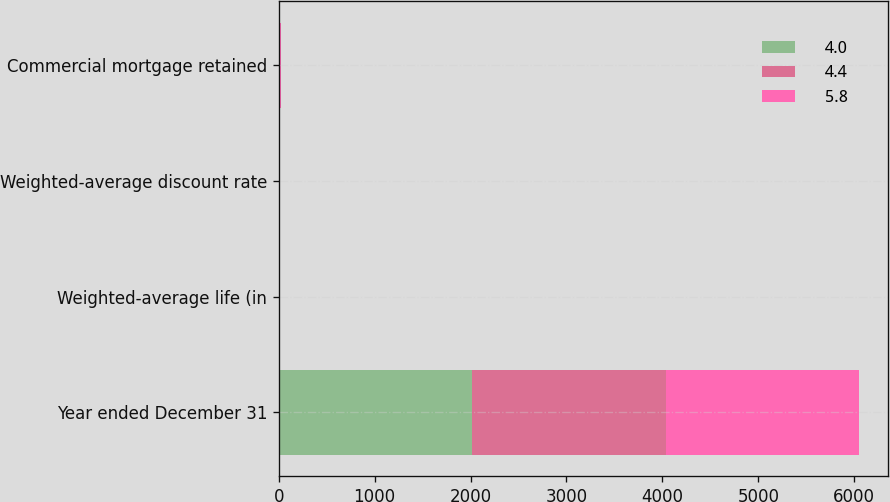Convert chart to OTSL. <chart><loc_0><loc_0><loc_500><loc_500><stacked_bar_chart><ecel><fcel>Year ended December 31<fcel>Weighted-average life (in<fcel>Weighted-average discount rate<fcel>Commercial mortgage retained<nl><fcel>4<fcel>2018<fcel>7.6<fcel>3.6<fcel>5.3<nl><fcel>4.4<fcel>2017<fcel>4.8<fcel>2.9<fcel>7.1<nl><fcel>5.8<fcel>2016<fcel>4.5<fcel>4.2<fcel>6.2<nl></chart> 